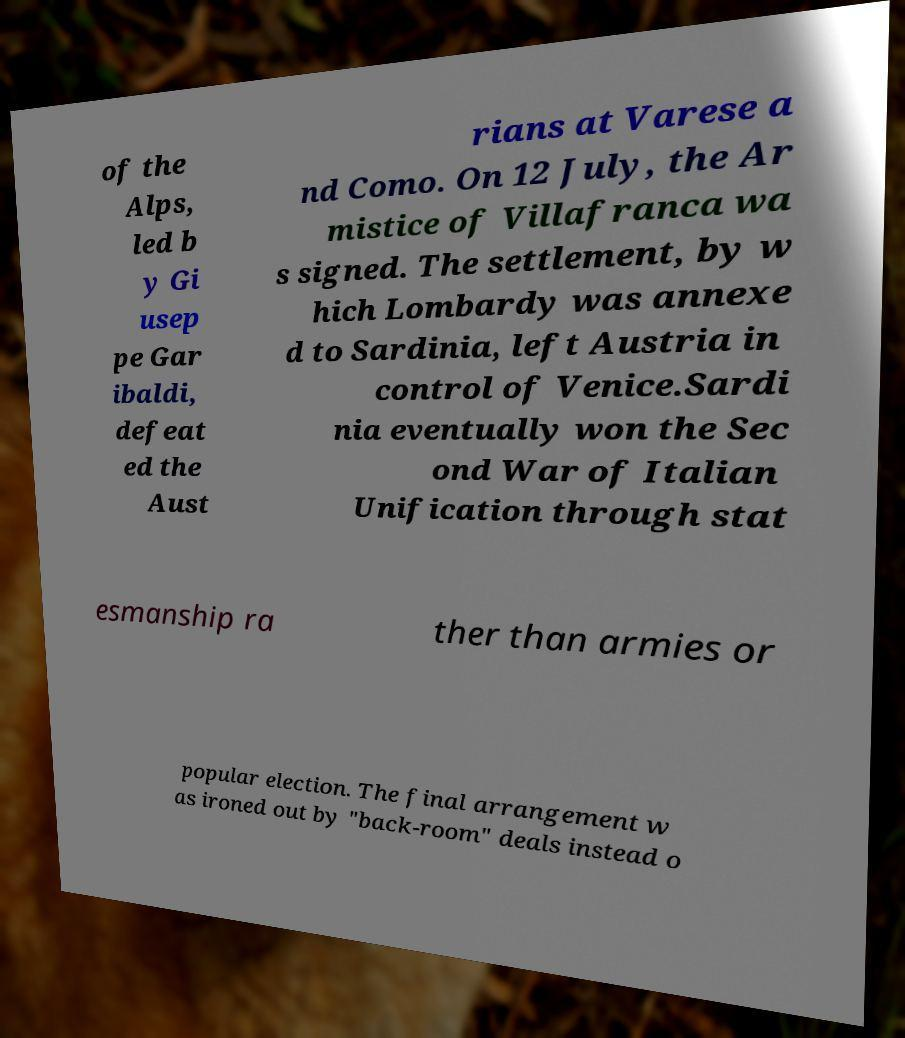Could you assist in decoding the text presented in this image and type it out clearly? of the Alps, led b y Gi usep pe Gar ibaldi, defeat ed the Aust rians at Varese a nd Como. On 12 July, the Ar mistice of Villafranca wa s signed. The settlement, by w hich Lombardy was annexe d to Sardinia, left Austria in control of Venice.Sardi nia eventually won the Sec ond War of Italian Unification through stat esmanship ra ther than armies or popular election. The final arrangement w as ironed out by "back-room" deals instead o 